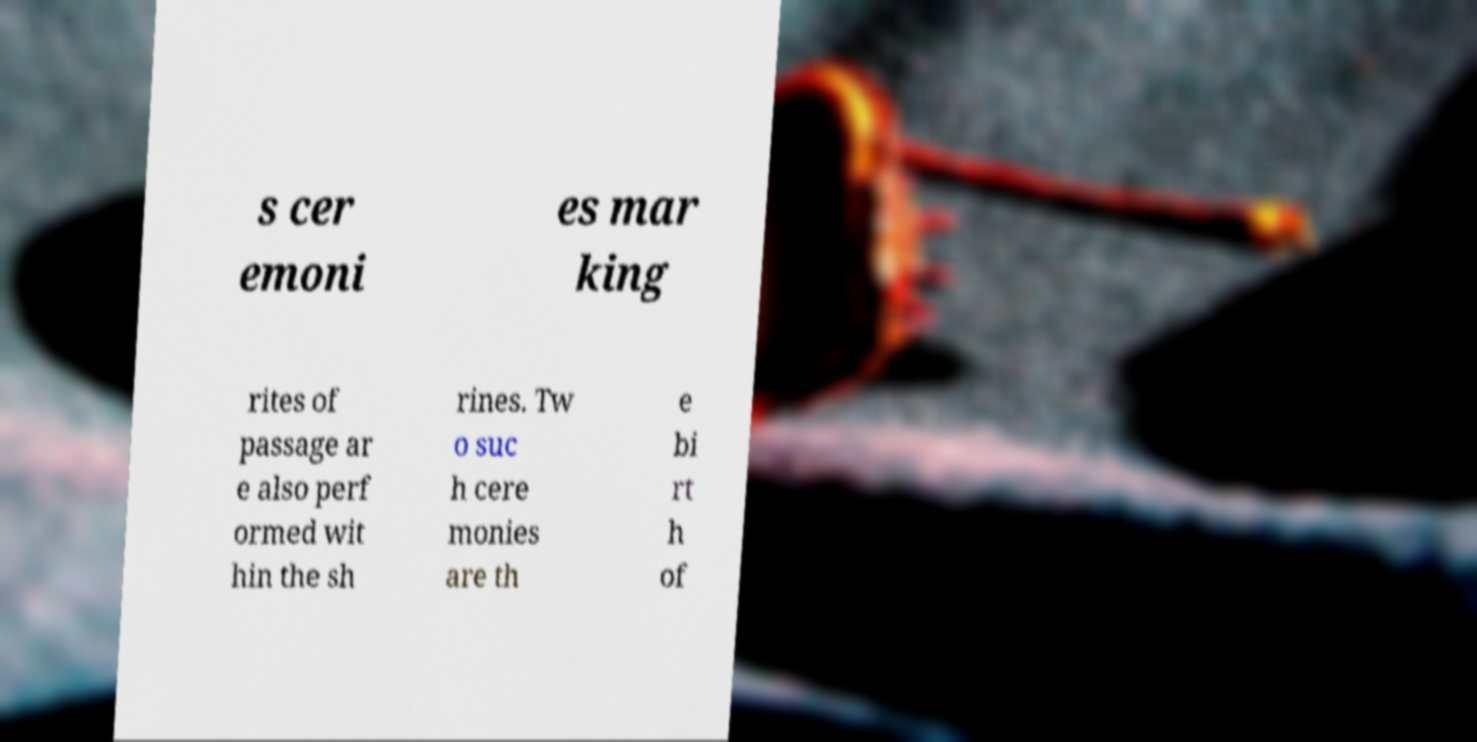There's text embedded in this image that I need extracted. Can you transcribe it verbatim? s cer emoni es mar king rites of passage ar e also perf ormed wit hin the sh rines. Tw o suc h cere monies are th e bi rt h of 